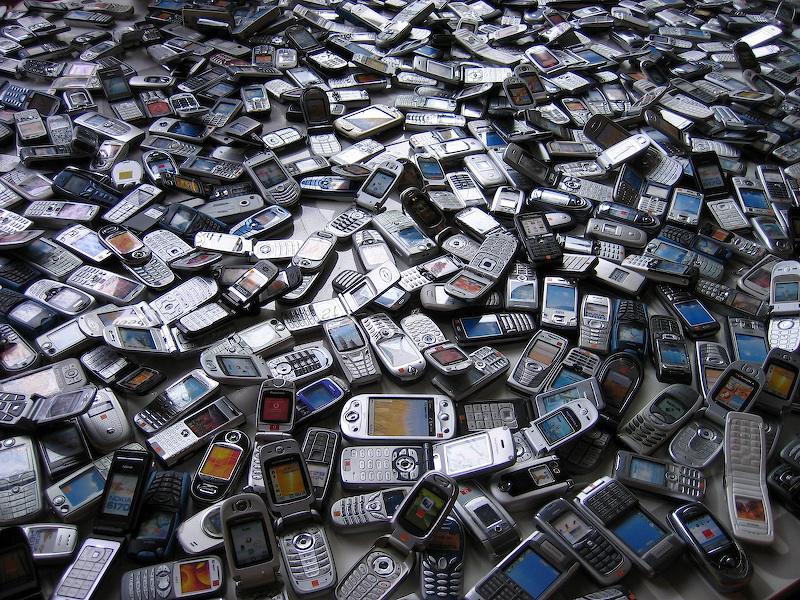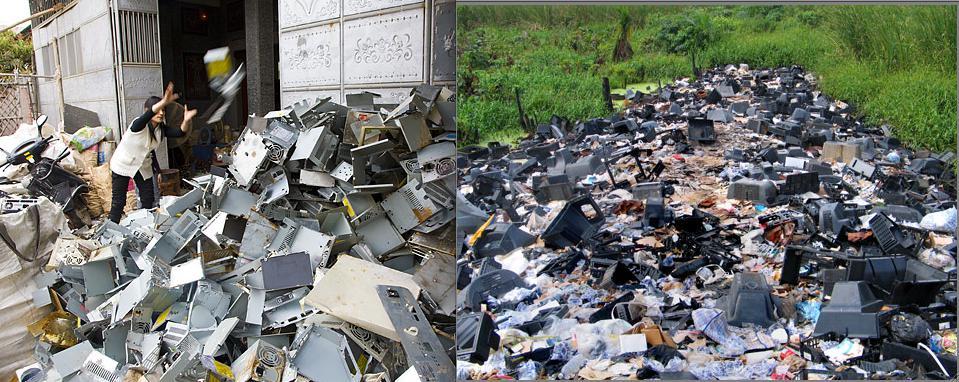The first image is the image on the left, the second image is the image on the right. Examine the images to the left and right. Is the description "There is exactly one person in the left image." accurate? Answer yes or no. No. 